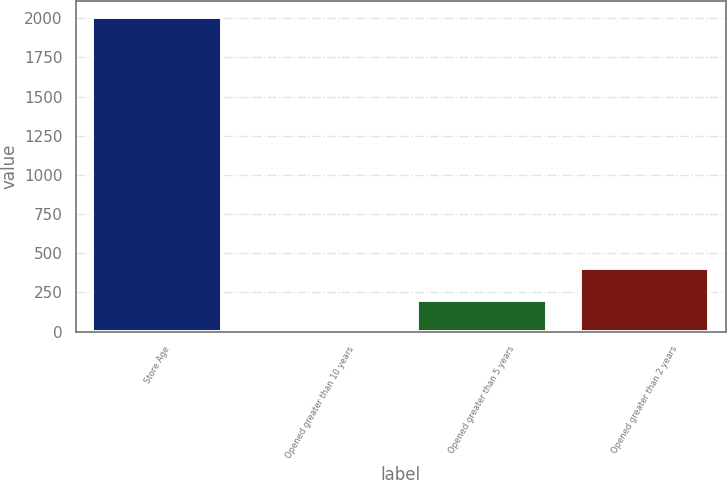Convert chart. <chart><loc_0><loc_0><loc_500><loc_500><bar_chart><fcel>Store Age<fcel>Opened greater than 10 years<fcel>Opened greater than 5 years<fcel>Opened greater than 2 years<nl><fcel>2007<fcel>4.4<fcel>204.66<fcel>404.92<nl></chart> 